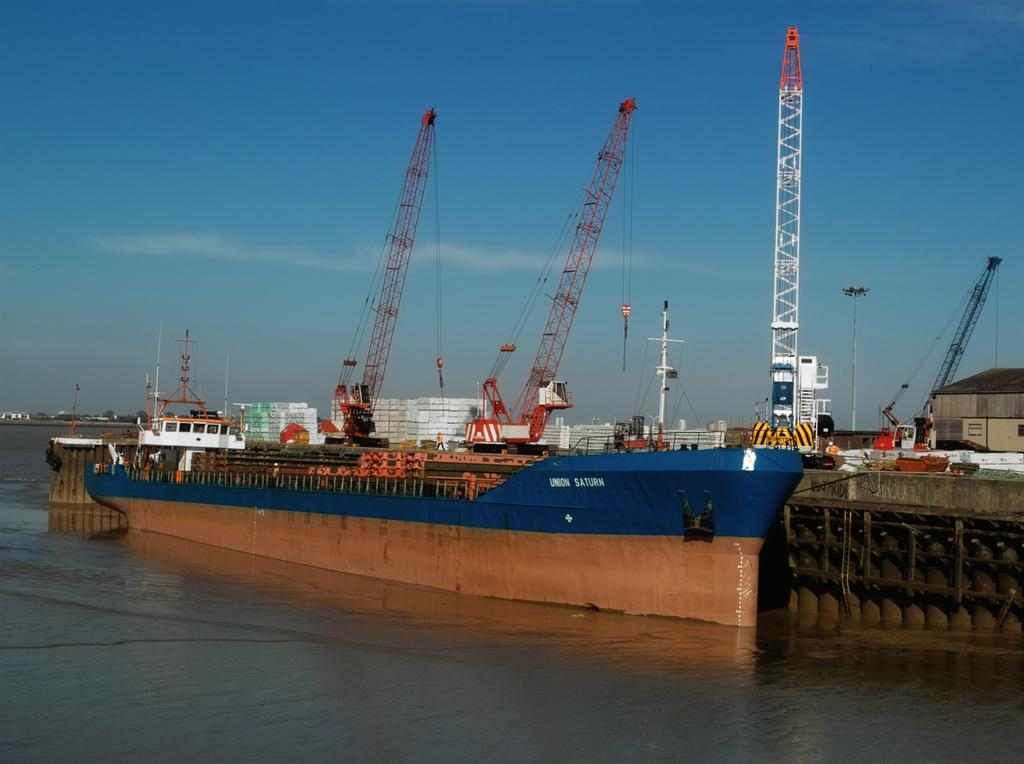What is the main subject of the image? The main subject of the image is a ship. Where is the ship located in the image? The ship is in the water. What type of plant can be seen growing on the slope near the ship in the image? There is no slope or plant visible in the image; it features a ship in the water. 